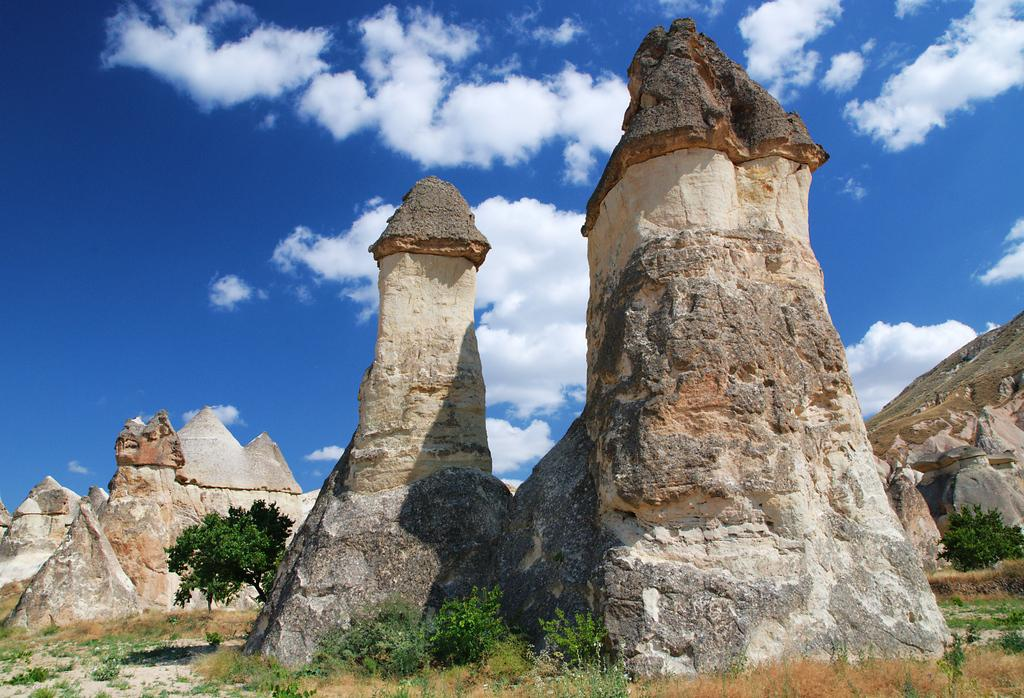What type of artwork can be seen in the image? There are sculptures in the image. What other natural elements are present in the image? There are trees in the image. What can be seen in the distance in the image? The sky is visible in the background of the image. What type of hat is the sculpture wearing in the image? There are no sculptures wearing hats in the image. What material is the silk used for in the image? There is no silk present in the image. 